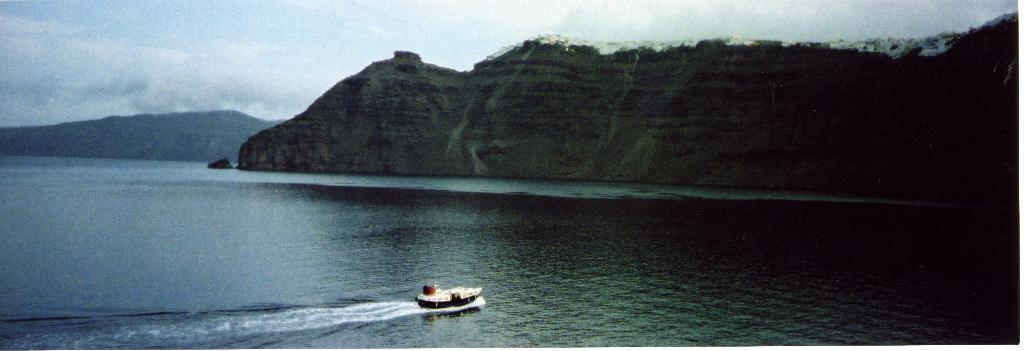What is the main subject of the image? The main subject of the image is a boat. Where is the boat located? The boat is in the water. What can be seen in the background of the image? Hills are visible in the background of the image. How would you describe the weather in the image? The sky is cloudy in the image, suggesting overcast or potentially rainy weather. Where is the aunt sitting with the lamp in the image? There is no aunt or lamp present in the image; it only features a boat in the water with hills in the background and a cloudy sky. 